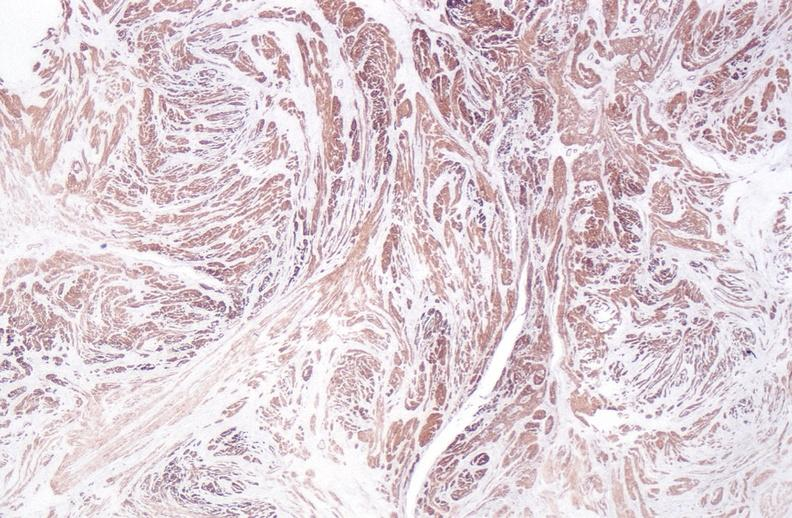where is this from?
Answer the question using a single word or phrase. Female reproductive system 